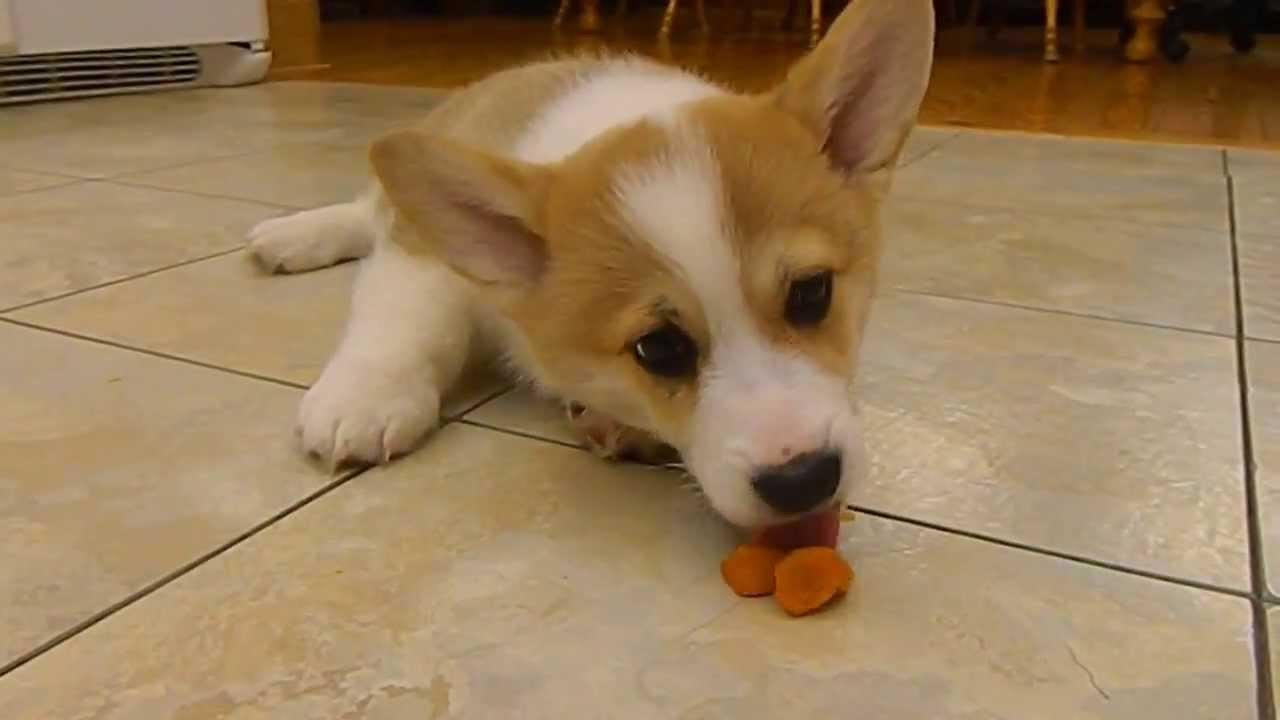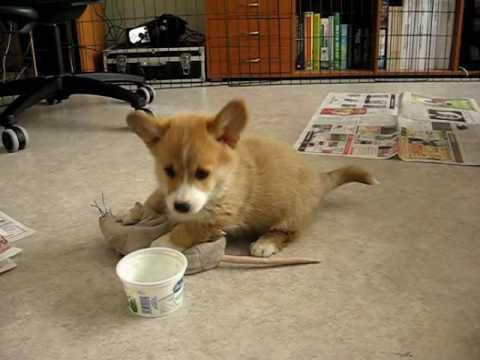The first image is the image on the left, the second image is the image on the right. For the images displayed, is the sentence "At least one puppy is outside." factually correct? Answer yes or no. No. The first image is the image on the left, the second image is the image on the right. Evaluate the accuracy of this statement regarding the images: "At least one pup is outside.". Is it true? Answer yes or no. No. 